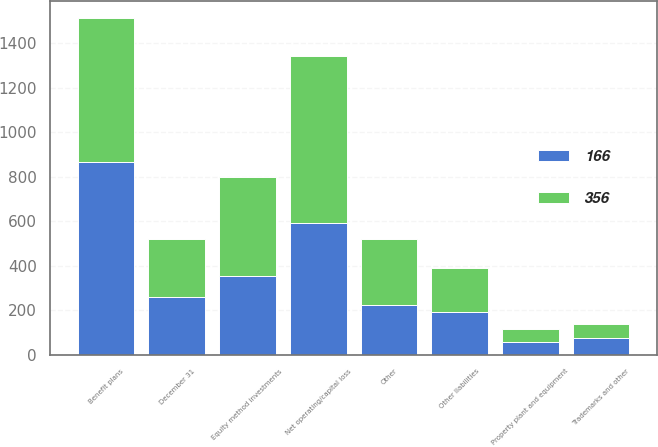<chart> <loc_0><loc_0><loc_500><loc_500><stacked_bar_chart><ecel><fcel>December 31<fcel>Property plant and equipment<fcel>Trademarks and other<fcel>Equity method investments<fcel>Other liabilities<fcel>Benefit plans<fcel>Net operating/capital loss<fcel>Other<nl><fcel>166<fcel>259.5<fcel>58<fcel>75<fcel>354<fcel>190<fcel>866<fcel>593<fcel>224<nl><fcel>356<fcel>259.5<fcel>60<fcel>64<fcel>445<fcel>200<fcel>649<fcel>750<fcel>295<nl></chart> 